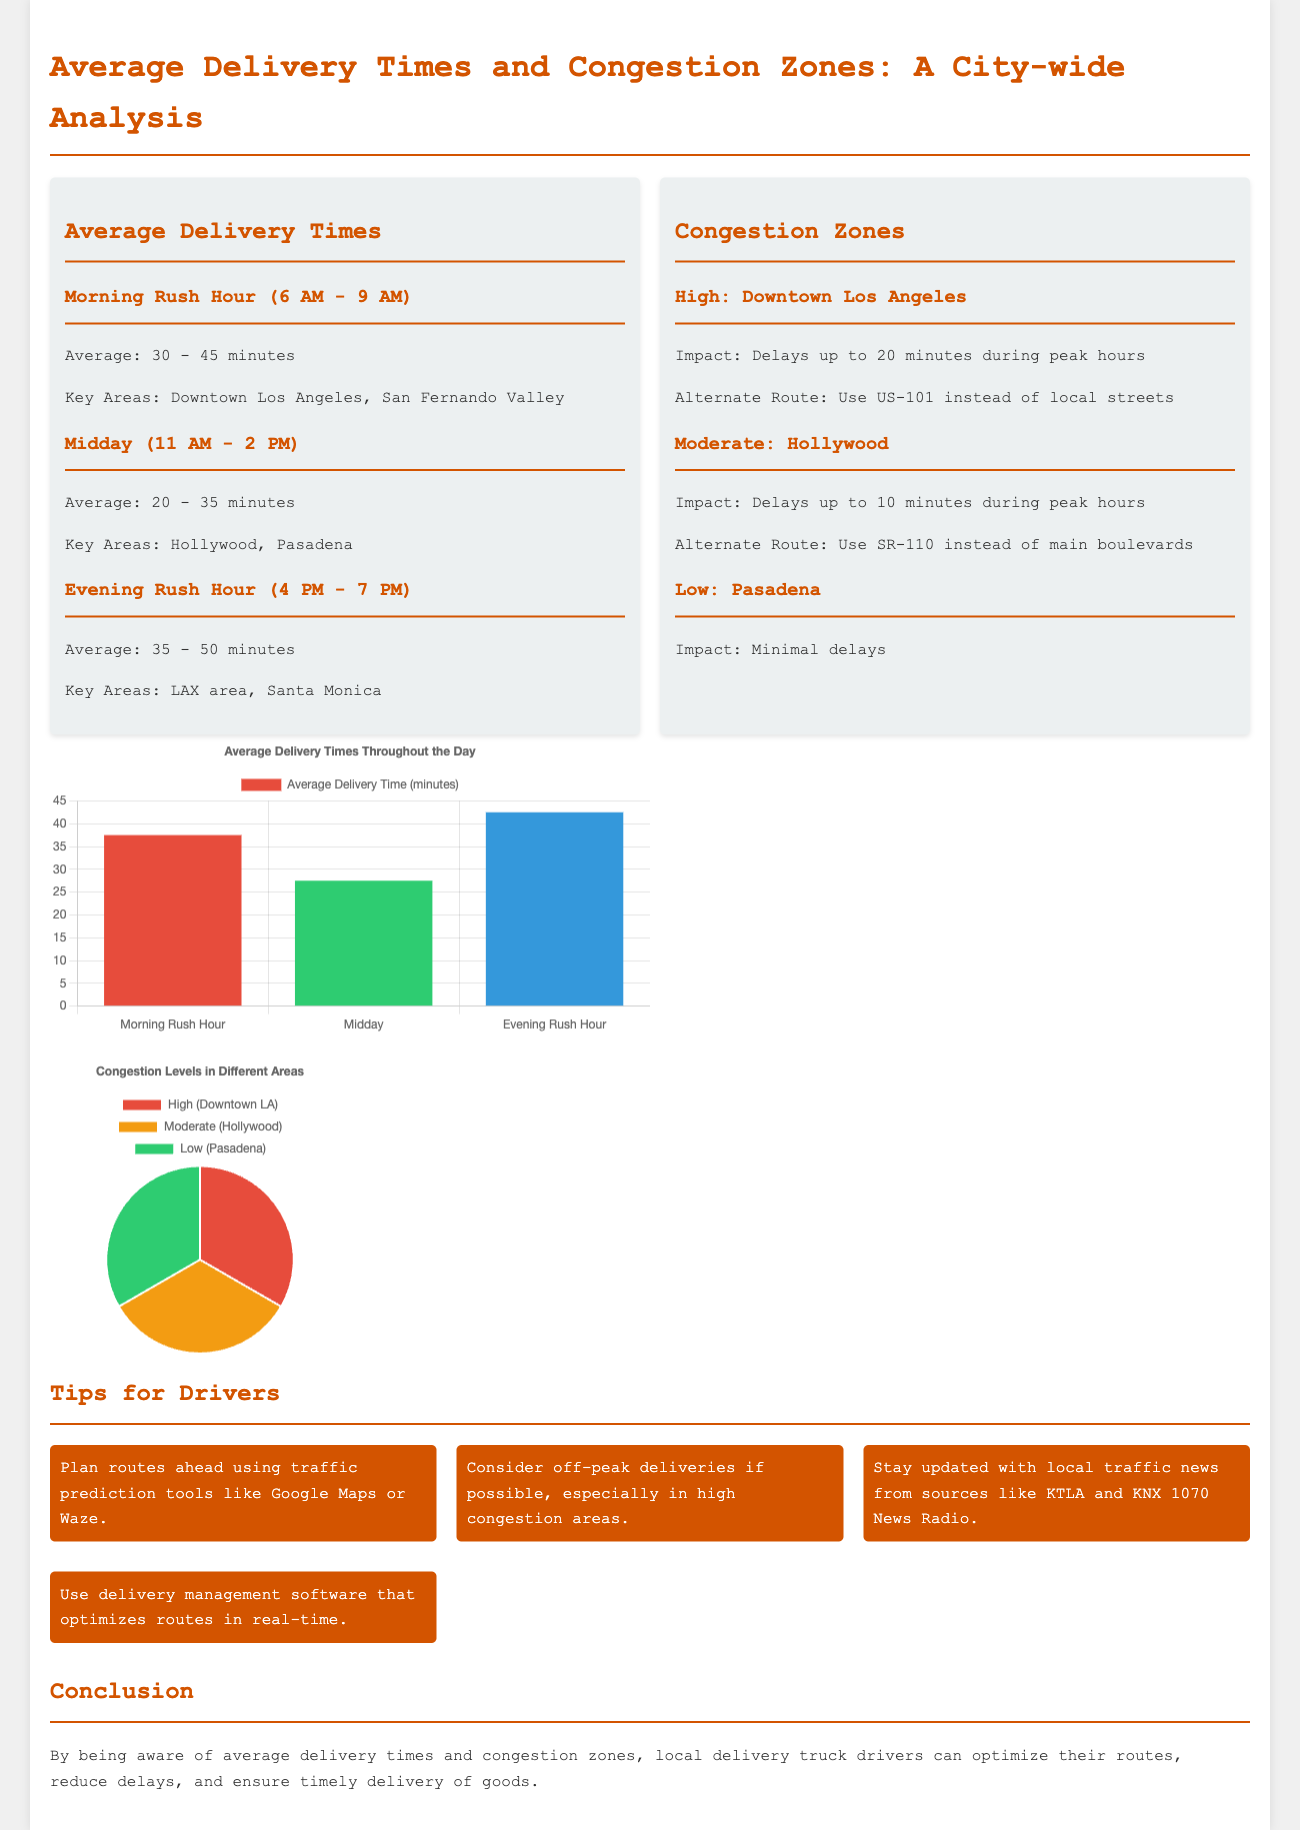What is the average delivery time during morning rush hour? The average delivery time during morning rush hour is stated as 30 - 45 minutes in the document.
Answer: 30 - 45 minutes What are the key areas for midday deliveries? The key areas for midday deliveries are mentioned in the document as Hollywood and Pasadena.
Answer: Hollywood, Pasadena What is the expected delay impact in high congestion zones? In high congestion zones, the document states that delays can be up to 20 minutes during peak hours.
Answer: 20 minutes Which alternate route is suggested for Downtown Los Angeles? The document suggests using US-101 instead of local streets as an alternate route for Downtown Los Angeles.
Answer: US-101 What is the average delivery time during midday? The average delivery time during midday is indicated as 20 - 35 minutes in the infographic.
Answer: 20 - 35 minutes What is the overall congestion level in Pasadena? The document describes the congestion level in Pasadena as low, with minimal delays.
Answer: Low What is the average delivery time during the evening rush hour? The average delivery time during the evening rush hour is given in the document as 35 - 50 minutes.
Answer: 35 - 50 minutes Which area has a moderate congestion level? The document states that Hollywood has a moderate congestion level.
Answer: Hollywood What traffic prediction tools are recommended for drivers? The document recommends using Google Maps or Waze for route planning.
Answer: Google Maps, Waze 